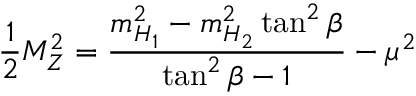<formula> <loc_0><loc_0><loc_500><loc_500>\frac { 1 } { 2 } M _ { Z } ^ { 2 } = \frac { m _ { H _ { 1 } } ^ { 2 } - m _ { H _ { 2 } } ^ { 2 } \tan ^ { 2 } \beta } { \tan ^ { 2 } \beta - 1 } - \mu ^ { 2 }</formula> 